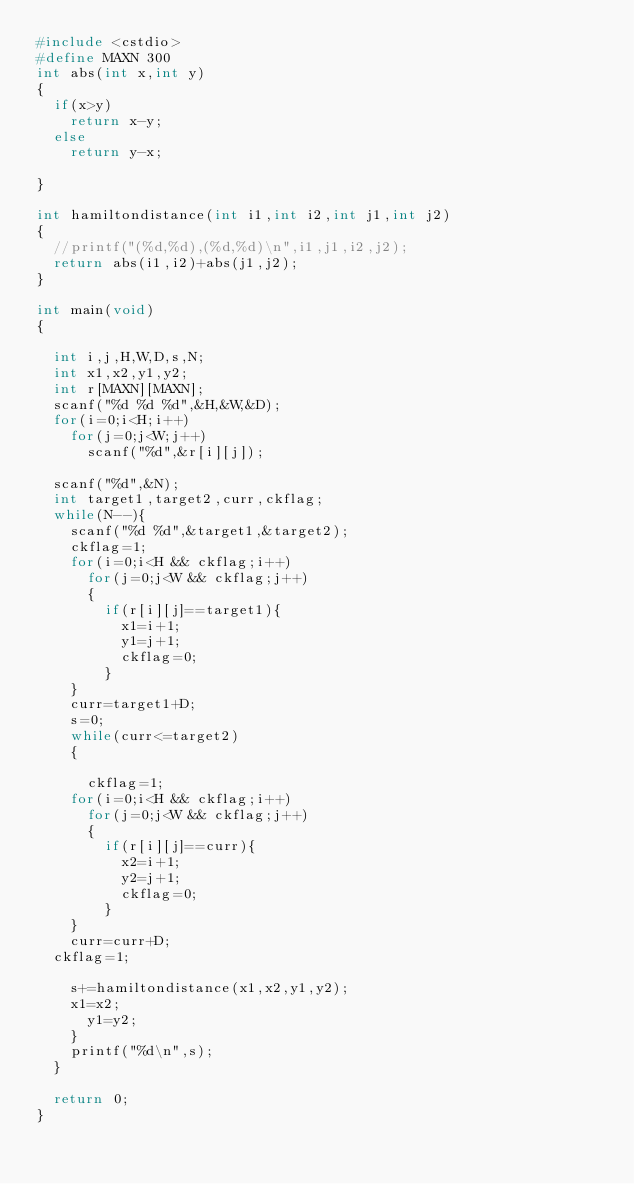<code> <loc_0><loc_0><loc_500><loc_500><_C++_>#include <cstdio>
#define MAXN 300
int abs(int x,int y)
{
	if(x>y)
		return x-y;
	else
		return y-x;

}

int hamiltondistance(int i1,int i2,int j1,int j2)
{
	//printf("(%d,%d),(%d,%d)\n",i1,j1,i2,j2);
	return abs(i1,i2)+abs(j1,j2);
}

int main(void)
{

	int i,j,H,W,D,s,N;
	int x1,x2,y1,y2;
	int r[MAXN][MAXN];
	scanf("%d %d %d",&H,&W,&D);
	for(i=0;i<H;i++)
		for(j=0;j<W;j++)
			scanf("%d",&r[i][j]);

	scanf("%d",&N);
	int target1,target2,curr,ckflag;
	while(N--){
		scanf("%d %d",&target1,&target2);
		ckflag=1;
		for(i=0;i<H && ckflag;i++)
			for(j=0;j<W && ckflag;j++)
			{
				if(r[i][j]==target1){
					x1=i+1;
					y1=j+1;
					ckflag=0;
				}
		}
		curr=target1+D;
		s=0;
		while(curr<=target2)
		{
			
			ckflag=1;
		for(i=0;i<H && ckflag;i++)
			for(j=0;j<W && ckflag;j++)
			{
				if(r[i][j]==curr){
					x2=i+1;
					y2=j+1;
					ckflag=0;
				}
		}
		curr=curr+D;
	ckflag=1;

		s+=hamiltondistance(x1,x2,y1,y2);
		x1=x2;
			y1=y2;
		}
		printf("%d\n",s);
	}

	return 0;
}</code> 